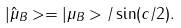<formula> <loc_0><loc_0><loc_500><loc_500>| { \hat { \mu } } _ { B } > = | \mu _ { B } > / \sin ( c / 2 ) .</formula> 